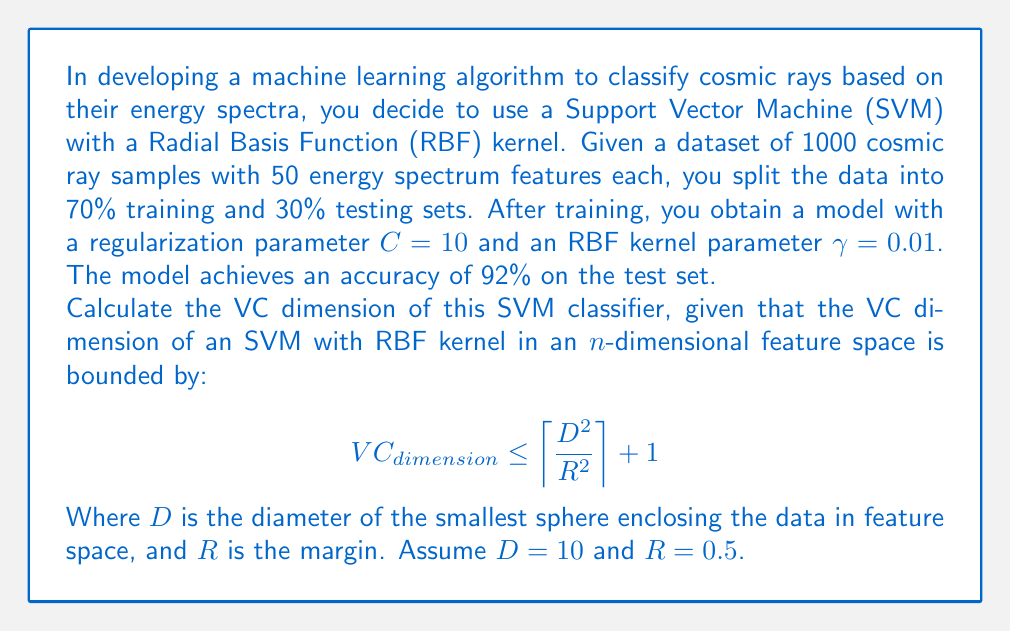What is the answer to this math problem? To solve this problem, we need to follow these steps:

1. Understand the given information:
   - We have an SVM classifier with RBF kernel
   - The feature space has 50 dimensions (energy spectrum features)
   - We're given the formula for the upper bound of VC dimension
   - We're provided with values for $D$ and $R$

2. Recall the formula for VC dimension upper bound:
   $$ VC_{dimension} \leq \left\lceil \frac{D^2}{R^2} \right\rceil + 1 $$

3. Substitute the given values:
   $D = 10$ (diameter of the smallest enclosing sphere)
   $R = 0.5$ (margin)

4. Calculate $\frac{D^2}{R^2}$:
   $$ \frac{D^2}{R^2} = \frac{10^2}{0.5^2} = \frac{100}{0.25} = 400 $$

5. Apply the ceiling function to this result:
   $$ \left\lceil \frac{D^2}{R^2} \right\rceil = \left\lceil 400 \right\rceil = 400 $$

6. Add 1 to the result as per the formula:
   $$ VC_{dimension} \leq 400 + 1 = 401 $$

Therefore, the VC dimension of this SVM classifier is bounded by 401.
Answer: The VC dimension of the SVM classifier is bounded by 401. 